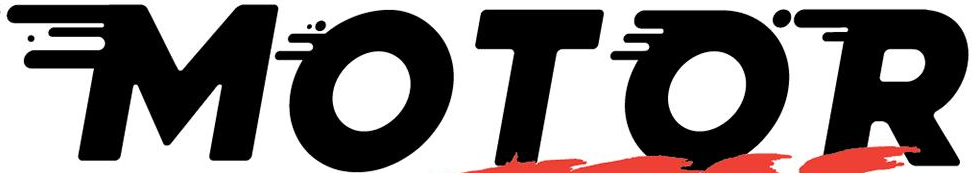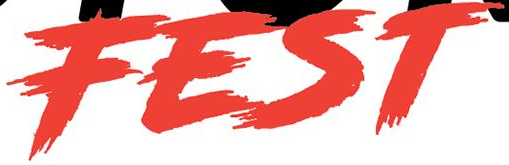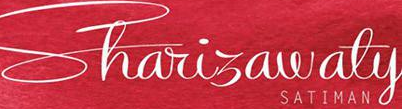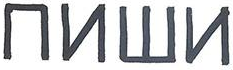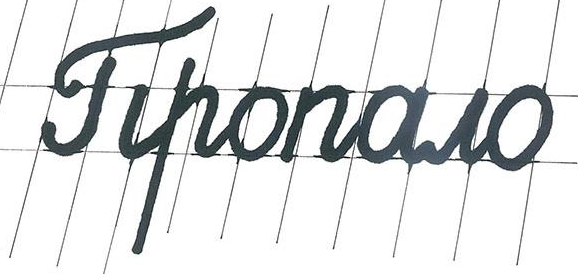What text appears in these images from left to right, separated by a semicolon? MOTOR; FEST; Shariɜawaty; ##W#; Tiponowo 